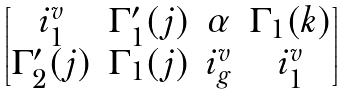Convert formula to latex. <formula><loc_0><loc_0><loc_500><loc_500>\begin{bmatrix} i ^ { v } _ { 1 } & \Gamma ^ { \prime } _ { 1 } ( j ) & \alpha & \Gamma _ { 1 } ( k ) \\ \Gamma ^ { \prime } _ { 2 } ( j ) & \Gamma _ { 1 } ( j ) & i ^ { v } _ { g } & i ^ { v } _ { 1 } \end{bmatrix}</formula> 